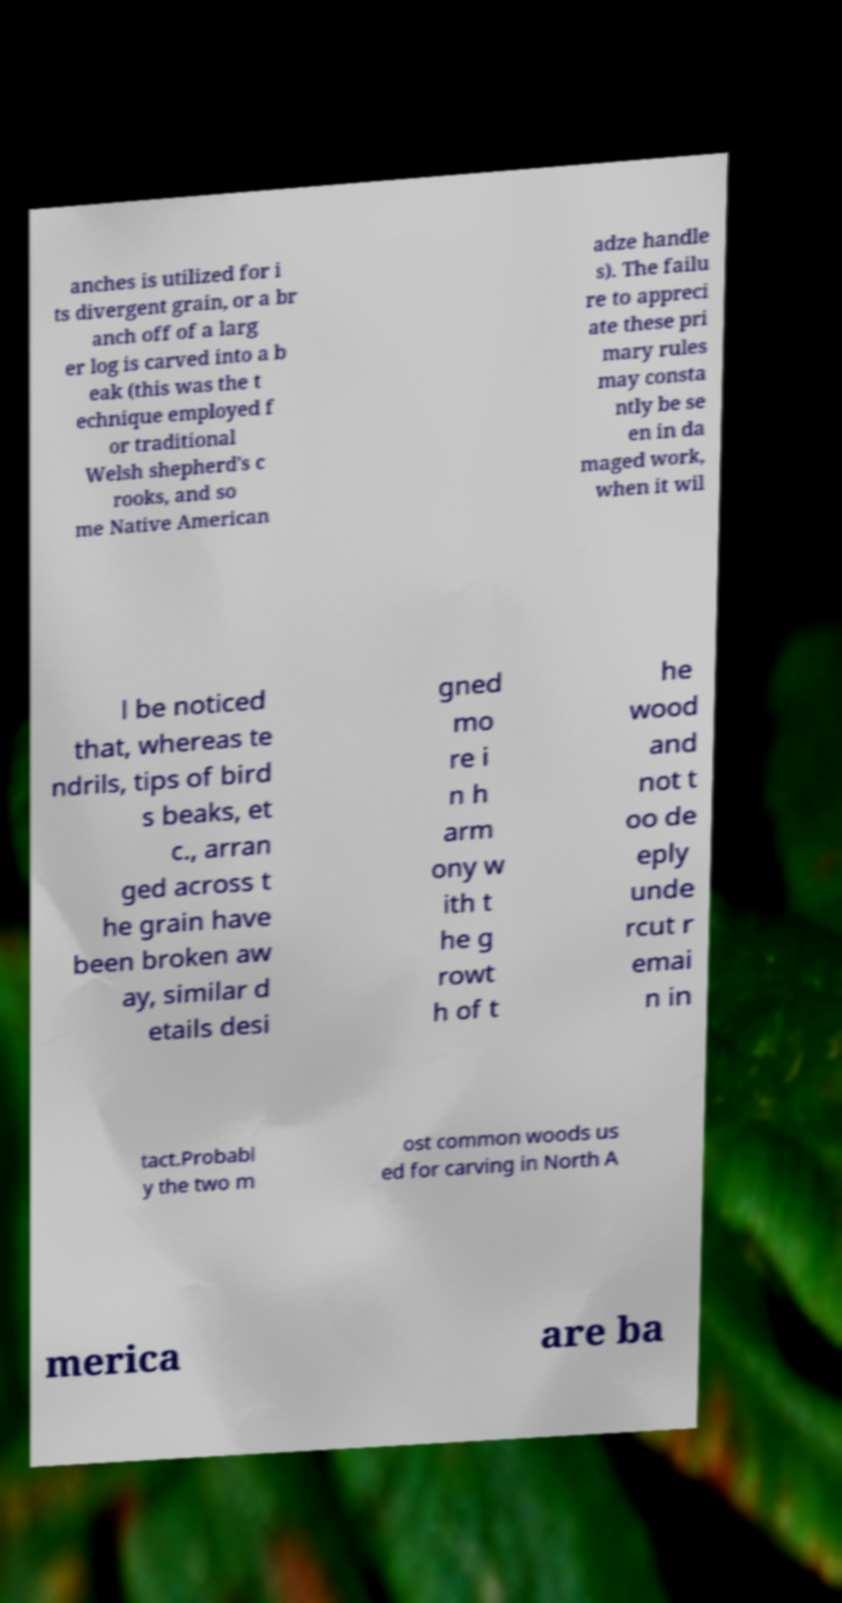Can you read and provide the text displayed in the image?This photo seems to have some interesting text. Can you extract and type it out for me? anches is utilized for i ts divergent grain, or a br anch off of a larg er log is carved into a b eak (this was the t echnique employed f or traditional Welsh shepherd's c rooks, and so me Native American adze handle s). The failu re to appreci ate these pri mary rules may consta ntly be se en in da maged work, when it wil l be noticed that, whereas te ndrils, tips of bird s beaks, et c., arran ged across t he grain have been broken aw ay, similar d etails desi gned mo re i n h arm ony w ith t he g rowt h of t he wood and not t oo de eply unde rcut r emai n in tact.Probabl y the two m ost common woods us ed for carving in North A merica are ba 